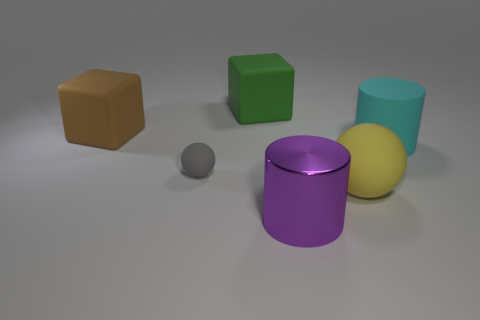Subtract 2 cylinders. How many cylinders are left? 0 Add 3 big brown objects. How many objects exist? 9 Subtract all purple cylinders. How many cylinders are left? 1 Subtract all cubes. How many objects are left? 4 Add 6 big cyan matte spheres. How many big cyan matte spheres exist? 6 Subtract 0 cyan cubes. How many objects are left? 6 Subtract all cyan blocks. Subtract all gray cylinders. How many blocks are left? 2 Subtract all purple spheres. How many red cylinders are left? 0 Subtract all small green rubber cylinders. Subtract all brown matte objects. How many objects are left? 5 Add 3 green rubber things. How many green rubber things are left? 4 